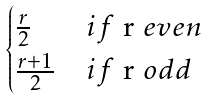Convert formula to latex. <formula><loc_0><loc_0><loc_500><loc_500>\begin{cases} \frac { r } { 2 } & i f $ r $ e v e n \\ \frac { r + 1 } { 2 } & i f $ r $ o d d \end{cases}</formula> 